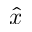<formula> <loc_0><loc_0><loc_500><loc_500>\hat { x }</formula> 